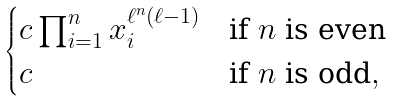<formula> <loc_0><loc_0><loc_500><loc_500>\begin{cases} c \prod _ { i = 1 } ^ { n } x _ { i } ^ { \ell ^ { n } ( \ell - 1 ) } & { \text {if $n$ is even} } \\ c & { \text {if $n$ is odd} } , \end{cases}</formula> 